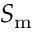<formula> <loc_0><loc_0><loc_500><loc_500>S _ { m }</formula> 